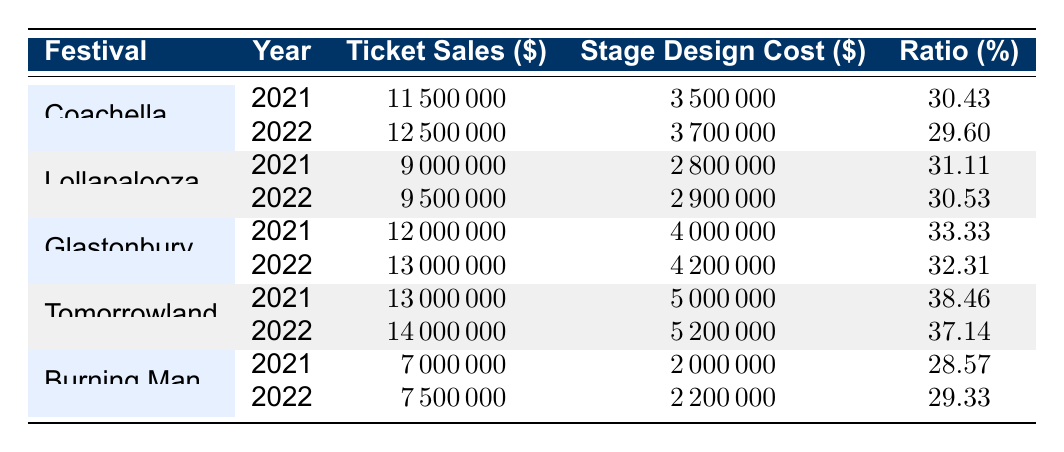What was the ticket sales amount for Tomorrowland in 2022? Tomorrowland's ticket sales in 2022 can be found in the table, specifically in the row for Tomorrowland under the year 2022. The value is 14,000,000.
Answer: 14000000 What is the ratio of stage design costs to ticket sales for Glastonbury in 2021? To find the ratio, look at the Glastonbury row for 2021. The ticket sales amount is 12,000,000 and the stage design cost is 4,000,000. The ratio is calculated as (Stage Design Cost / Ticket Sales) * 100, which is (4,000,000 / 12,000,000) * 100 = 33.33%.
Answer: 33.33 Did Burning Man have a higher stage design cost in 2022 compared to 2021? To determine this, compare the stage design costs for Burning Man in both years. In 2021, the cost was 2,000,000 and in 2022, it was 2,200,000. Since 2,200,000 is greater than 2,000,000, the answer is yes.
Answer: Yes What is the average stage design cost for all festivals in 2021? To find the average, sum all stage design costs for 2021: (3,500,000 + 2,800,000 + 4,000,000 + 5,000,000 + 2,000,000) = 17,300,000. Divide this by the number of festivals (5), resulting in an average stage design cost of 17,300,000 / 5 = 3,460,000.
Answer: 3460000 Was the ticket sales amount for Lollapalooza in 2022 higher than the stage design costs for the same year? Compare Lollapalooza's ticket sales in 2022 (9,500,000) with its stage design costs for the same year (2,900,000). Since 9,500,000 is greater than 2,900,000, the statement is true.
Answer: Yes What was the total ticket sales for Coachella across both years? To find the total, add up the ticket sales amounts for Coachella in both years: 11,500,000 (2021) + 12,500,000 (2022) = 24,000,000.
Answer: 24000000 Which festival had the highest stage design cost in 2021? Look at all the stage design costs for 2021 and identify the maximum value. Tomorrowland had the highest cost at 5,000,000.
Answer: Tomorrowland What is the difference in ticket sales amount for Glastonbury between 2021 and 2022? Calculate the difference by taking the ticket sales for 2022 (13,000,000) and subtract the 2021 amount (12,000,000): 13,000,000 - 12,000,000 = 1,000,000.
Answer: 1000000 